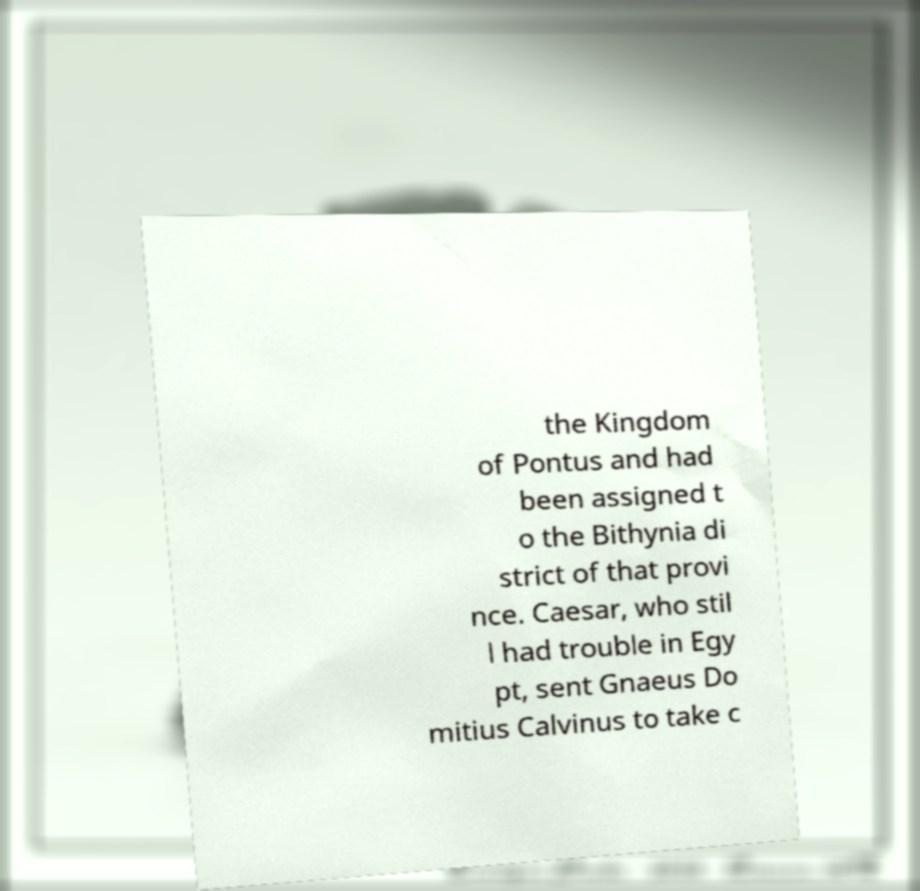Could you extract and type out the text from this image? the Kingdom of Pontus and had been assigned t o the Bithynia di strict of that provi nce. Caesar, who stil l had trouble in Egy pt, sent Gnaeus Do mitius Calvinus to take c 